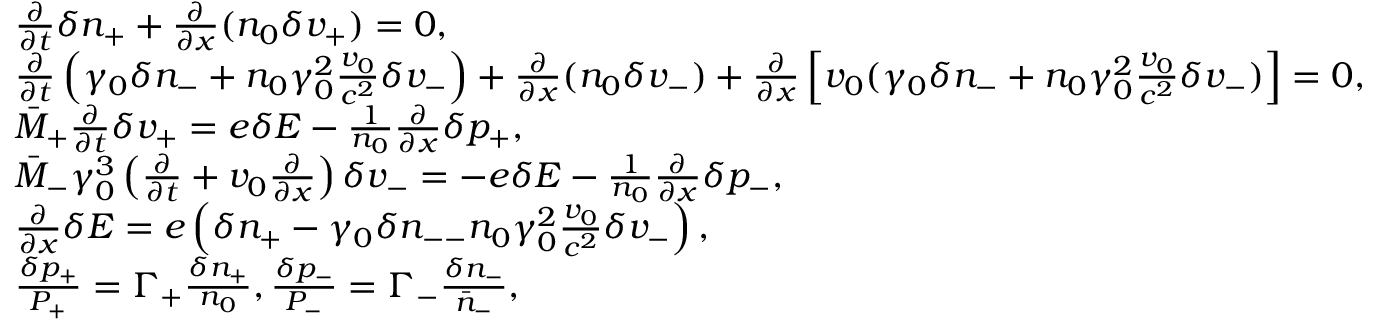<formula> <loc_0><loc_0><loc_500><loc_500>\begin{array} { r l } & { \frac { \partial } { \partial t } \delta n _ { + } + \frac { \partial } { \partial x } ( n _ { 0 } \delta v _ { + } ) = 0 , } \\ & { \frac { \partial } { \partial t } \left ( \gamma _ { 0 } \delta n _ { - } + n _ { 0 } \gamma _ { 0 } ^ { 2 } \frac { v _ { 0 } } { c ^ { 2 } } \delta v _ { - } \right ) + \frac { \partial } { \partial x } ( n _ { 0 } \delta v _ { - } ) + \frac { \partial } { \partial x } \left [ v _ { 0 } ( \gamma _ { 0 } \delta n _ { - } + n _ { 0 } \gamma _ { 0 } ^ { 2 } \frac { v _ { 0 } } { c ^ { 2 } } \delta v _ { - } ) \right ] = 0 , } \\ & { \bar { M } _ { + } \frac { \partial } { \partial t } \delta v _ { + } = e \delta E - \frac { 1 } { n _ { 0 } } \frac { \partial } { \partial x } \delta p _ { + } , } \\ & { \bar { M } _ { - } \gamma _ { 0 } ^ { 3 } \left ( \frac { \partial } { \partial t } + v _ { 0 } \frac { \partial } { \partial x } \right ) \delta v _ { - } = - e \delta E - \frac { 1 } { n _ { 0 } } \frac { \partial } { \partial x } \delta p _ { - } , } \\ & { \frac { \partial } { \partial x } \delta E = e \left ( \delta n _ { + } - \gamma _ { 0 } \delta n _ { - - } n _ { 0 } \gamma _ { 0 } ^ { 2 } \frac { v _ { 0 } } { c ^ { 2 } } \delta v _ { - } \right ) , } \\ & { \frac { \delta p _ { + } } { P _ { + } } = \Gamma _ { + } \frac { \delta n _ { + } } { n _ { 0 } } , \frac { \delta p _ { - } } { P _ { - } } = \Gamma _ { - } \frac { \delta n _ { - } } { \bar { n } _ { - } } , } \end{array}</formula> 